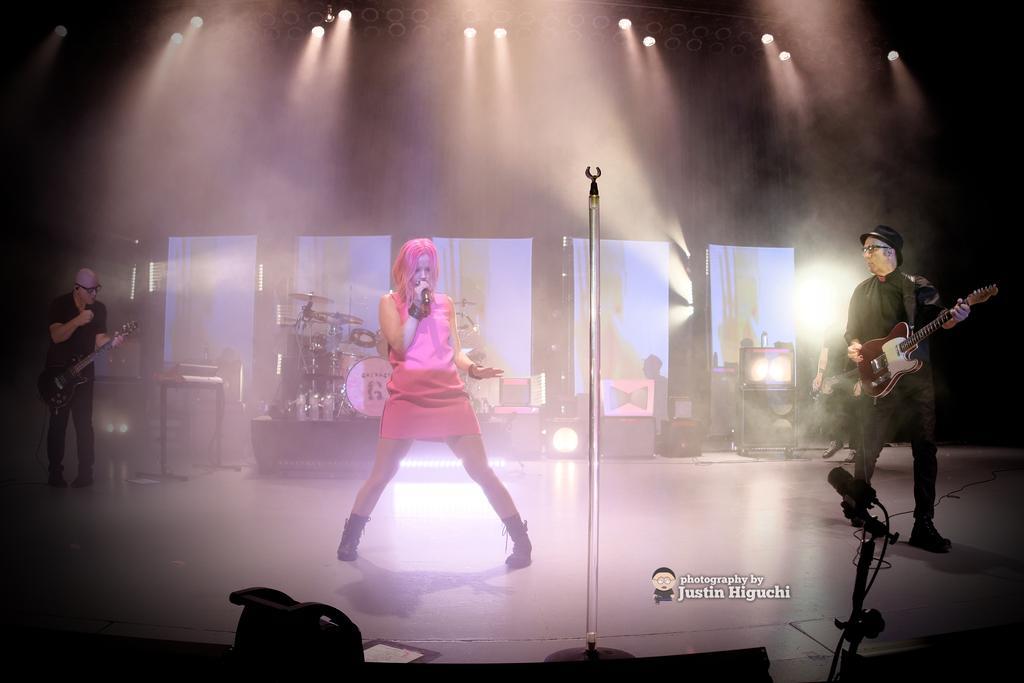In one or two sentences, can you explain what this image depicts? At the top we can see lights. On the background we can see musical instruments. We can see two men standing and playing guitars. We can see a women standing and holding a mike in her hand and singing. This is a platform. 